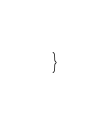<code> <loc_0><loc_0><loc_500><loc_500><_CSS_>}

</code> 